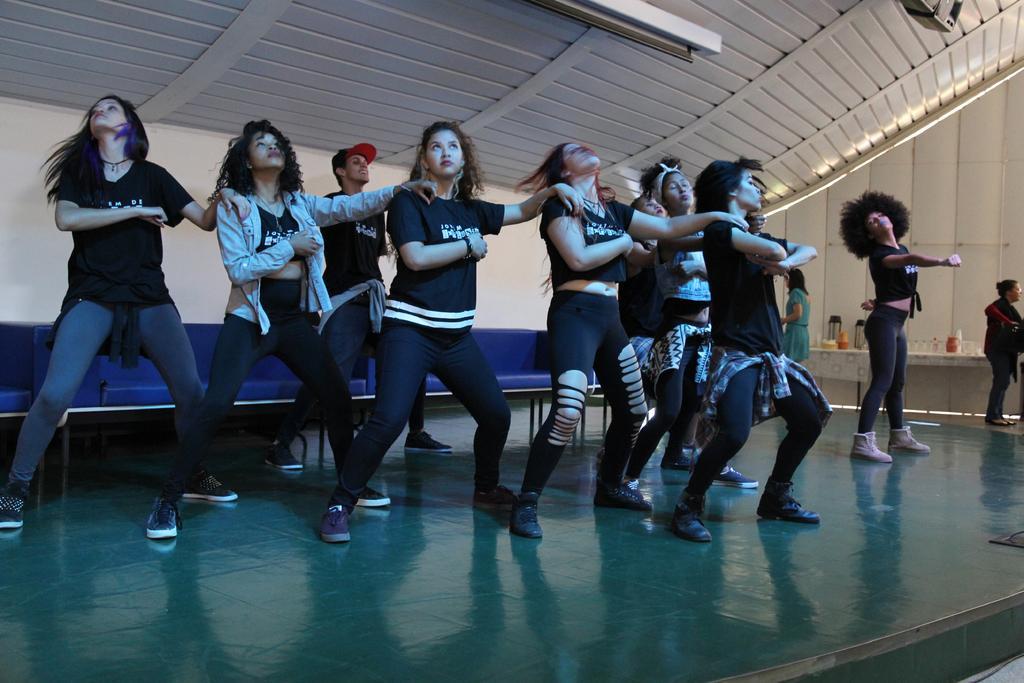In one or two sentences, can you explain what this image depicts? In the center of the image we can see ladies dancing on the floor. In the background there is a sofa and we can see a wall. 